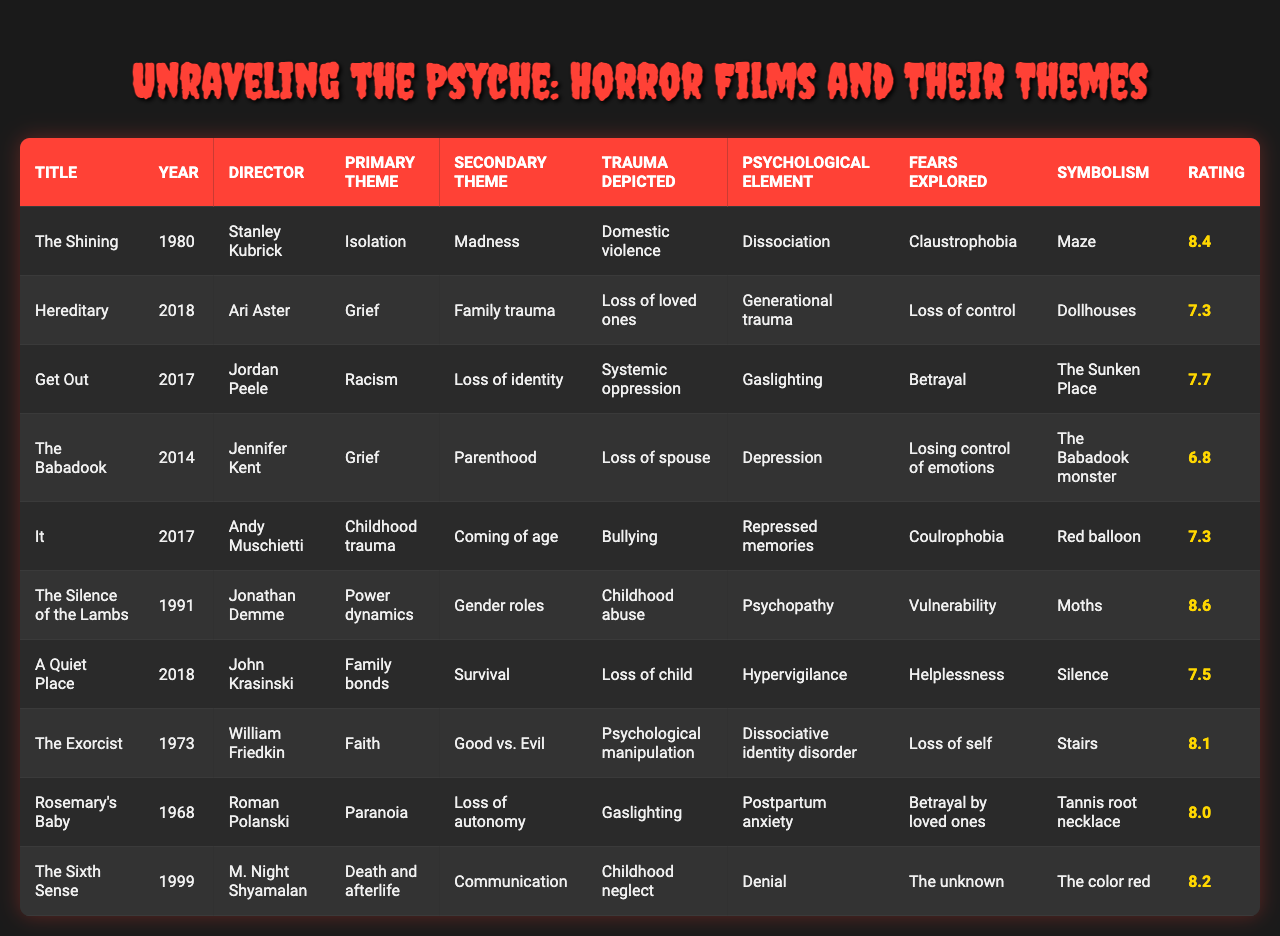What is the primary theme of "Get Out"? By looking at the row for "Get Out," the primary theme is directly listed as "Racism."
Answer: Racism Which film depicts childhood neglect? The film "The Sixth Sense" is noted to depict "Childhood neglect" under the trauma depicted column.
Answer: The Sixth Sense What is the highest-rated film in the table? The film with the highest critical acclaim is "The Silence of the Lambs" with a rating of 8.6.
Answer: The Silence of the Lambs How many films focus on grief as a primary theme? "Hereditary" and "The Babadook" are the two films with "Grief" as the primary theme, making a total of 2.
Answer: 2 What year was "The Exorcist" released? The release year for "The Exorcist" is listed as 1973 in the table.
Answer: 1973 Which film explores the fear of losing control of emotions? The film "The Babadook" explores the fear of losing control of emotions as noted in the fears explored column.
Answer: The Babadook What psychological element is depicted in "Hereditary"? In "Hereditary," the psychological element is identified as "Generational trauma."
Answer: Generational trauma Are there any films that depict psychological manipulation as trauma? Yes, "The Exorcist" denotes "Psychological manipulation" as the trauma depicted.
Answer: Yes Which film combines themes of power dynamics and gender roles? "The Silence of the Lambs" combines the primary theme of "Power dynamics" with the secondary theme of "Gender roles."
Answer: The Silence of the Lambs What is the average critical acclaim rating of the films focusing on family themes? The films "Hereditary," "The Babadook," and "A Quiet Place" are focused on family themes, with ratings of 7.3, 6.8, and 7.5, respectively. The average is (7.3 + 6.8 + 7.5) / 3 = 7.2.
Answer: 7.2 Which film uses a maze as a symbolism? The symbolism of a maze is used in "The Shining.”
Answer: The Shining What is the secondary theme of "It"? The secondary theme of "It" is "Coming of age," as evident in the table.
Answer: Coming of age 